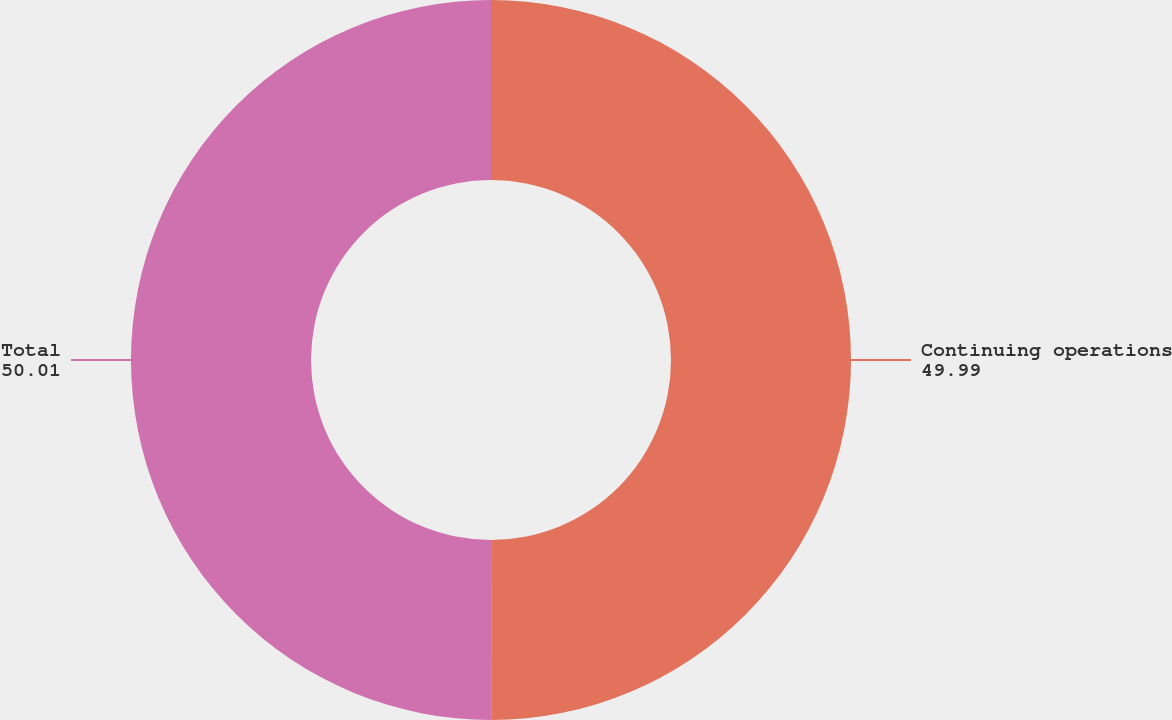Convert chart. <chart><loc_0><loc_0><loc_500><loc_500><pie_chart><fcel>Continuing operations<fcel>Total<nl><fcel>49.99%<fcel>50.01%<nl></chart> 